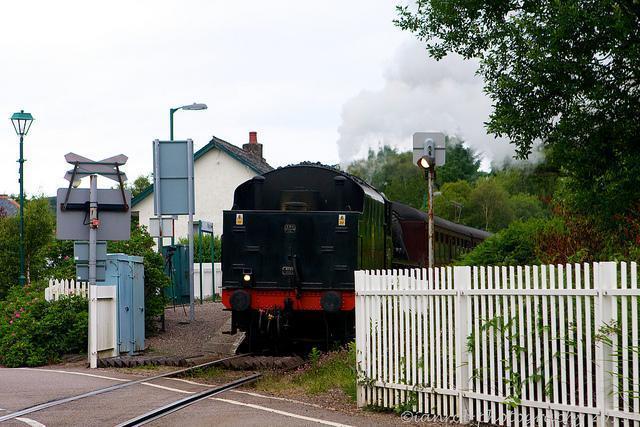How many street lamps are there?
Give a very brief answer. 2. 